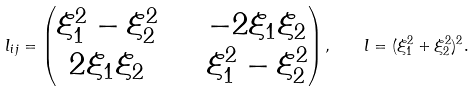Convert formula to latex. <formula><loc_0><loc_0><loc_500><loc_500>l _ { i j } = \begin{pmatrix} \xi _ { 1 } ^ { 2 } - \xi _ { 2 } ^ { 2 } & \quad - 2 \xi _ { 1 } \xi _ { 2 } \\ 2 \xi _ { 1 } \xi _ { 2 } & \quad \xi _ { 1 } ^ { 2 } - \xi _ { 2 } ^ { 2 } \end{pmatrix} , \quad l = ( \xi _ { 1 } ^ { 2 } + \xi _ { 2 } ^ { 2 } ) ^ { 2 } .</formula> 